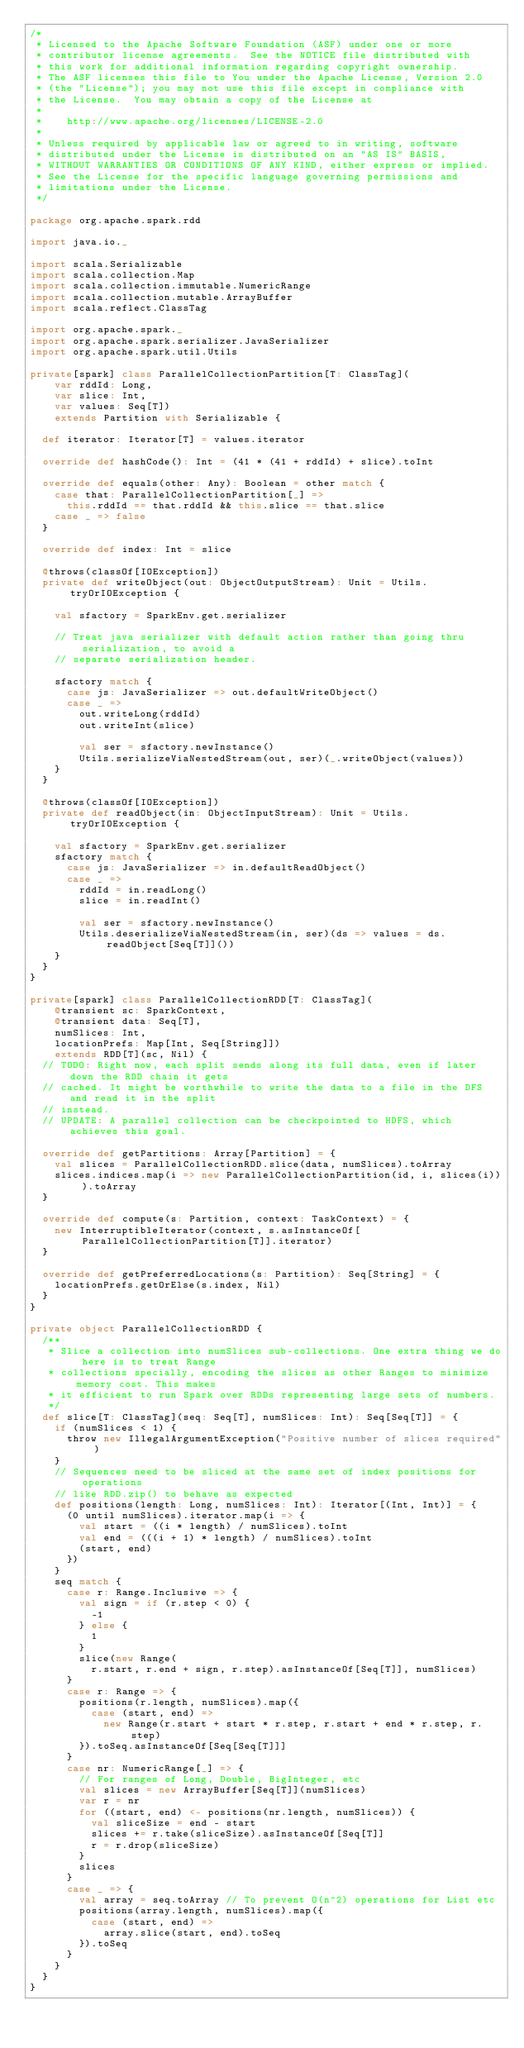Convert code to text. <code><loc_0><loc_0><loc_500><loc_500><_Scala_>/*
 * Licensed to the Apache Software Foundation (ASF) under one or more
 * contributor license agreements.  See the NOTICE file distributed with
 * this work for additional information regarding copyright ownership.
 * The ASF licenses this file to You under the Apache License, Version 2.0
 * (the "License"); you may not use this file except in compliance with
 * the License.  You may obtain a copy of the License at
 *
 *    http://www.apache.org/licenses/LICENSE-2.0
 *
 * Unless required by applicable law or agreed to in writing, software
 * distributed under the License is distributed on an "AS IS" BASIS,
 * WITHOUT WARRANTIES OR CONDITIONS OF ANY KIND, either express or implied.
 * See the License for the specific language governing permissions and
 * limitations under the License.
 */

package org.apache.spark.rdd

import java.io._

import scala.Serializable
import scala.collection.Map
import scala.collection.immutable.NumericRange
import scala.collection.mutable.ArrayBuffer
import scala.reflect.ClassTag

import org.apache.spark._
import org.apache.spark.serializer.JavaSerializer
import org.apache.spark.util.Utils

private[spark] class ParallelCollectionPartition[T: ClassTag](
    var rddId: Long,
    var slice: Int,
    var values: Seq[T])
    extends Partition with Serializable {

  def iterator: Iterator[T] = values.iterator

  override def hashCode(): Int = (41 * (41 + rddId) + slice).toInt

  override def equals(other: Any): Boolean = other match {
    case that: ParallelCollectionPartition[_] =>
      this.rddId == that.rddId && this.slice == that.slice
    case _ => false
  }

  override def index: Int = slice

  @throws(classOf[IOException])
  private def writeObject(out: ObjectOutputStream): Unit = Utils.tryOrIOException {

    val sfactory = SparkEnv.get.serializer

    // Treat java serializer with default action rather than going thru serialization, to avoid a
    // separate serialization header.

    sfactory match {
      case js: JavaSerializer => out.defaultWriteObject()
      case _ =>
        out.writeLong(rddId)
        out.writeInt(slice)

        val ser = sfactory.newInstance()
        Utils.serializeViaNestedStream(out, ser)(_.writeObject(values))
    }
  }

  @throws(classOf[IOException])
  private def readObject(in: ObjectInputStream): Unit = Utils.tryOrIOException {

    val sfactory = SparkEnv.get.serializer
    sfactory match {
      case js: JavaSerializer => in.defaultReadObject()
      case _ =>
        rddId = in.readLong()
        slice = in.readInt()

        val ser = sfactory.newInstance()
        Utils.deserializeViaNestedStream(in, ser)(ds => values = ds.readObject[Seq[T]]())
    }
  }
}

private[spark] class ParallelCollectionRDD[T: ClassTag](
    @transient sc: SparkContext,
    @transient data: Seq[T],
    numSlices: Int,
    locationPrefs: Map[Int, Seq[String]])
    extends RDD[T](sc, Nil) {
  // TODO: Right now, each split sends along its full data, even if later down the RDD chain it gets
  // cached. It might be worthwhile to write the data to a file in the DFS and read it in the split
  // instead.
  // UPDATE: A parallel collection can be checkpointed to HDFS, which achieves this goal.

  override def getPartitions: Array[Partition] = {
    val slices = ParallelCollectionRDD.slice(data, numSlices).toArray
    slices.indices.map(i => new ParallelCollectionPartition(id, i, slices(i))).toArray
  }

  override def compute(s: Partition, context: TaskContext) = {
    new InterruptibleIterator(context, s.asInstanceOf[ParallelCollectionPartition[T]].iterator)
  }

  override def getPreferredLocations(s: Partition): Seq[String] = {
    locationPrefs.getOrElse(s.index, Nil)
  }
}

private object ParallelCollectionRDD {
  /**
   * Slice a collection into numSlices sub-collections. One extra thing we do here is to treat Range
   * collections specially, encoding the slices as other Ranges to minimize memory cost. This makes
   * it efficient to run Spark over RDDs representing large sets of numbers.
   */
  def slice[T: ClassTag](seq: Seq[T], numSlices: Int): Seq[Seq[T]] = {
    if (numSlices < 1) {
      throw new IllegalArgumentException("Positive number of slices required")
    }
    // Sequences need to be sliced at the same set of index positions for operations
    // like RDD.zip() to behave as expected
    def positions(length: Long, numSlices: Int): Iterator[(Int, Int)] = {
      (0 until numSlices).iterator.map(i => {
        val start = ((i * length) / numSlices).toInt
        val end = (((i + 1) * length) / numSlices).toInt
        (start, end)
      })
    }
    seq match {
      case r: Range.Inclusive => {
        val sign = if (r.step < 0) {
          -1
        } else {
          1
        }
        slice(new Range(
          r.start, r.end + sign, r.step).asInstanceOf[Seq[T]], numSlices)
      }
      case r: Range => {
        positions(r.length, numSlices).map({
          case (start, end) =>
            new Range(r.start + start * r.step, r.start + end * r.step, r.step)
        }).toSeq.asInstanceOf[Seq[Seq[T]]]
      }
      case nr: NumericRange[_] => {
        // For ranges of Long, Double, BigInteger, etc
        val slices = new ArrayBuffer[Seq[T]](numSlices)
        var r = nr
        for ((start, end) <- positions(nr.length, numSlices)) {
          val sliceSize = end - start
          slices += r.take(sliceSize).asInstanceOf[Seq[T]]
          r = r.drop(sliceSize)
        }
        slices
      }
      case _ => {
        val array = seq.toArray // To prevent O(n^2) operations for List etc
        positions(array.length, numSlices).map({
          case (start, end) =>
            array.slice(start, end).toSeq
        }).toSeq
      }
    }
  }
}
</code> 